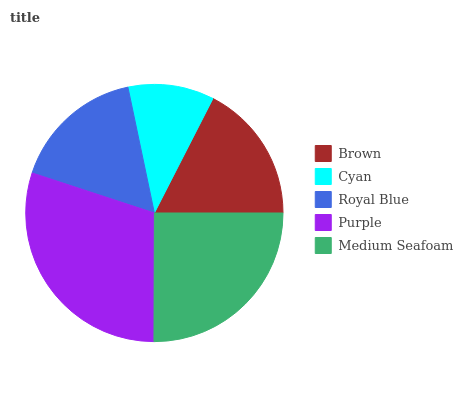Is Cyan the minimum?
Answer yes or no. Yes. Is Purple the maximum?
Answer yes or no. Yes. Is Royal Blue the minimum?
Answer yes or no. No. Is Royal Blue the maximum?
Answer yes or no. No. Is Royal Blue greater than Cyan?
Answer yes or no. Yes. Is Cyan less than Royal Blue?
Answer yes or no. Yes. Is Cyan greater than Royal Blue?
Answer yes or no. No. Is Royal Blue less than Cyan?
Answer yes or no. No. Is Brown the high median?
Answer yes or no. Yes. Is Brown the low median?
Answer yes or no. Yes. Is Cyan the high median?
Answer yes or no. No. Is Purple the low median?
Answer yes or no. No. 